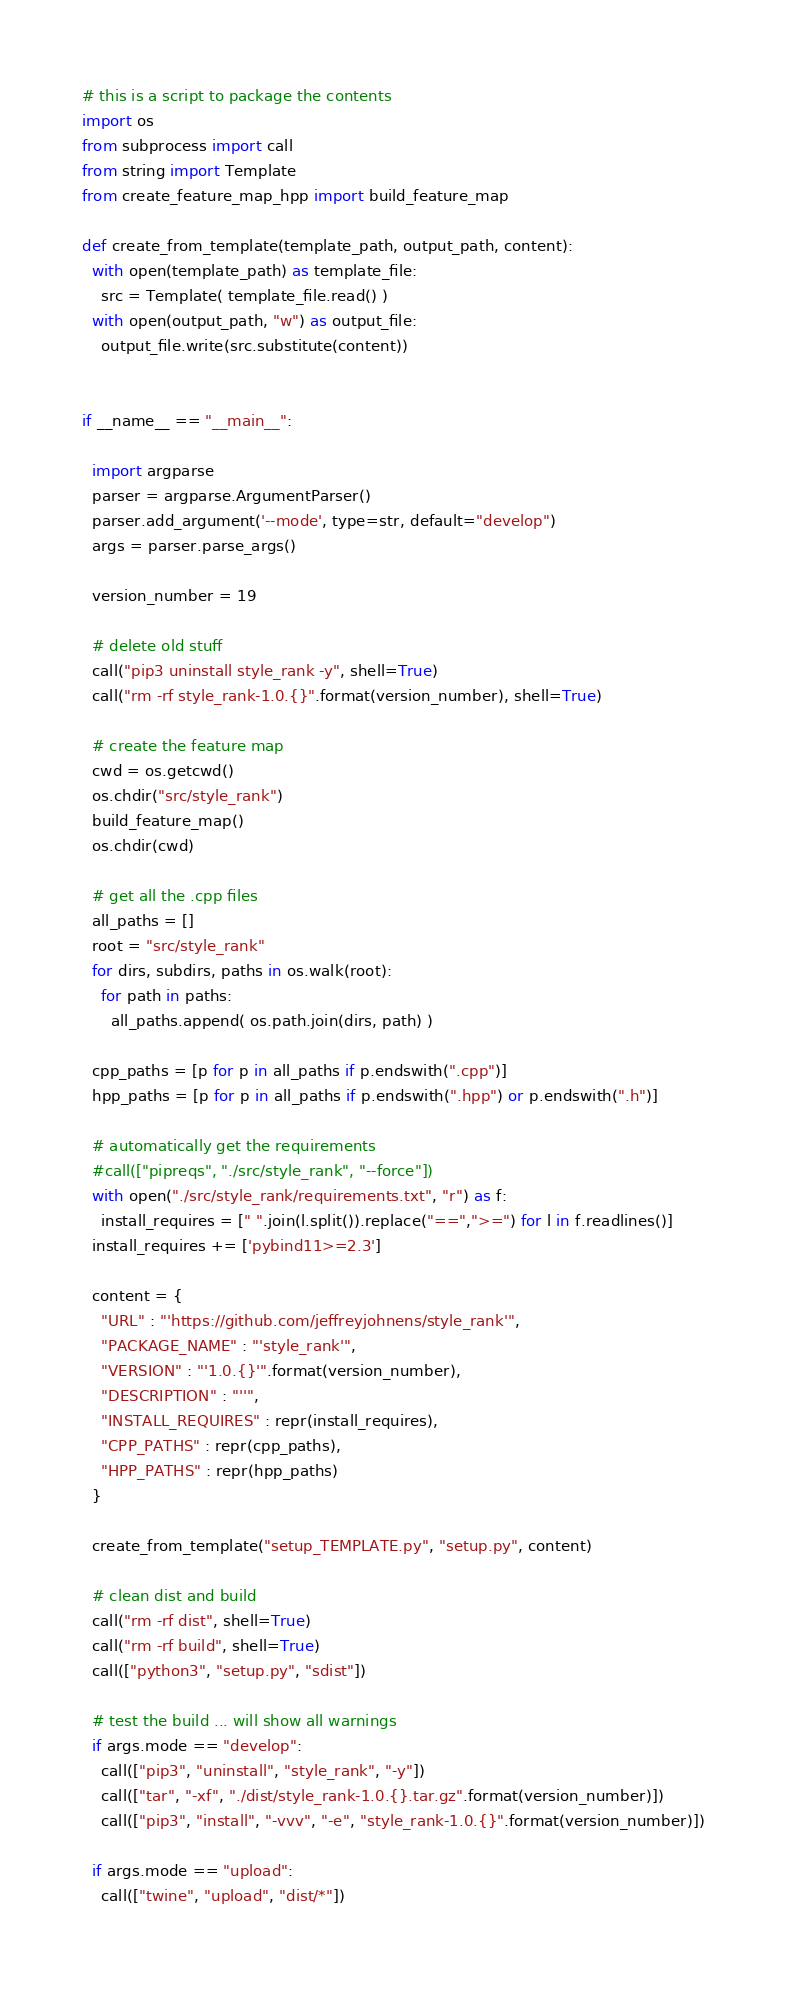<code> <loc_0><loc_0><loc_500><loc_500><_Python_># this is a script to package the contents
import os
from subprocess import call
from string import Template
from create_feature_map_hpp import build_feature_map

def create_from_template(template_path, output_path, content):
  with open(template_path) as template_file:
    src = Template( template_file.read() )
  with open(output_path, "w") as output_file:
    output_file.write(src.substitute(content))


if __name__ == "__main__":

  import argparse
  parser = argparse.ArgumentParser()
  parser.add_argument('--mode', type=str, default="develop")
  args = parser.parse_args()

  version_number = 19

  # delete old stuff
  call("pip3 uninstall style_rank -y", shell=True)
  call("rm -rf style_rank-1.0.{}".format(version_number), shell=True)

  # create the feature map
  cwd = os.getcwd()
  os.chdir("src/style_rank")
  build_feature_map()
  os.chdir(cwd)

  # get all the .cpp files
  all_paths = []
  root = "src/style_rank"
  for dirs, subdirs, paths in os.walk(root):
    for path in paths:
      all_paths.append( os.path.join(dirs, path) )

  cpp_paths = [p for p in all_paths if p.endswith(".cpp")]
  hpp_paths = [p for p in all_paths if p.endswith(".hpp") or p.endswith(".h")]

  # automatically get the requirements
  #call(["pipreqs", "./src/style_rank", "--force"])
  with open("./src/style_rank/requirements.txt", "r") as f:
    install_requires = [" ".join(l.split()).replace("==",">=") for l in f.readlines()]
  install_requires += ['pybind11>=2.3']

  content = {
    "URL" : "'https://github.com/jeffreyjohnens/style_rank'",
    "PACKAGE_NAME" : "'style_rank'",
    "VERSION" : "'1.0.{}'".format(version_number),
    "DESCRIPTION" : "''",
    "INSTALL_REQUIRES" : repr(install_requires),
    "CPP_PATHS" : repr(cpp_paths),
    "HPP_PATHS" : repr(hpp_paths)
  }

  create_from_template("setup_TEMPLATE.py", "setup.py", content)

  # clean dist and build
  call("rm -rf dist", shell=True)
  call("rm -rf build", shell=True)
  call(["python3", "setup.py", "sdist"])

  # test the build ... will show all warnings
  if args.mode == "develop":
    call(["pip3", "uninstall", "style_rank", "-y"])
    call(["tar", "-xf", "./dist/style_rank-1.0.{}.tar.gz".format(version_number)])
    call(["pip3", "install", "-vvv", "-e", "style_rank-1.0.{}".format(version_number)])
  
  if args.mode == "upload":
    call(["twine", "upload", "dist/*"])</code> 